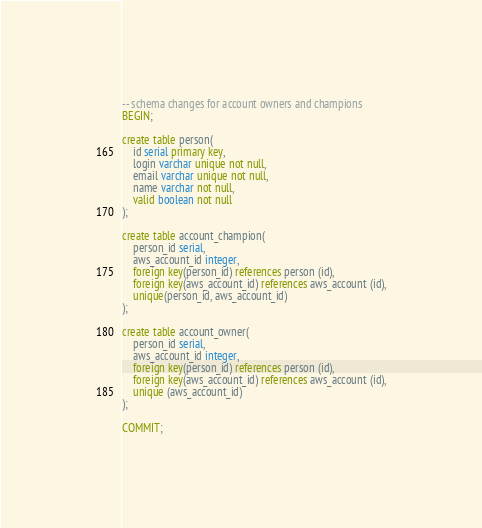<code> <loc_0><loc_0><loc_500><loc_500><_SQL_>-- schema changes for account owners and champions
BEGIN;

create table person(
    id serial primary key,
    login varchar unique not null,
    email varchar unique not null,
    name varchar not null,
    valid boolean not null
);

create table account_champion(
    person_id serial,
    aws_account_id integer,
    foreign key(person_id) references person (id),
    foreign key(aws_account_id) references aws_account (id),
    unique(person_id, aws_account_id)
);

create table account_owner(
    person_id serial,
    aws_account_id integer,
    foreign key(person_id) references person (id),
    foreign key(aws_account_id) references aws_account (id),
    unique (aws_account_id)
);

COMMIT;
</code> 